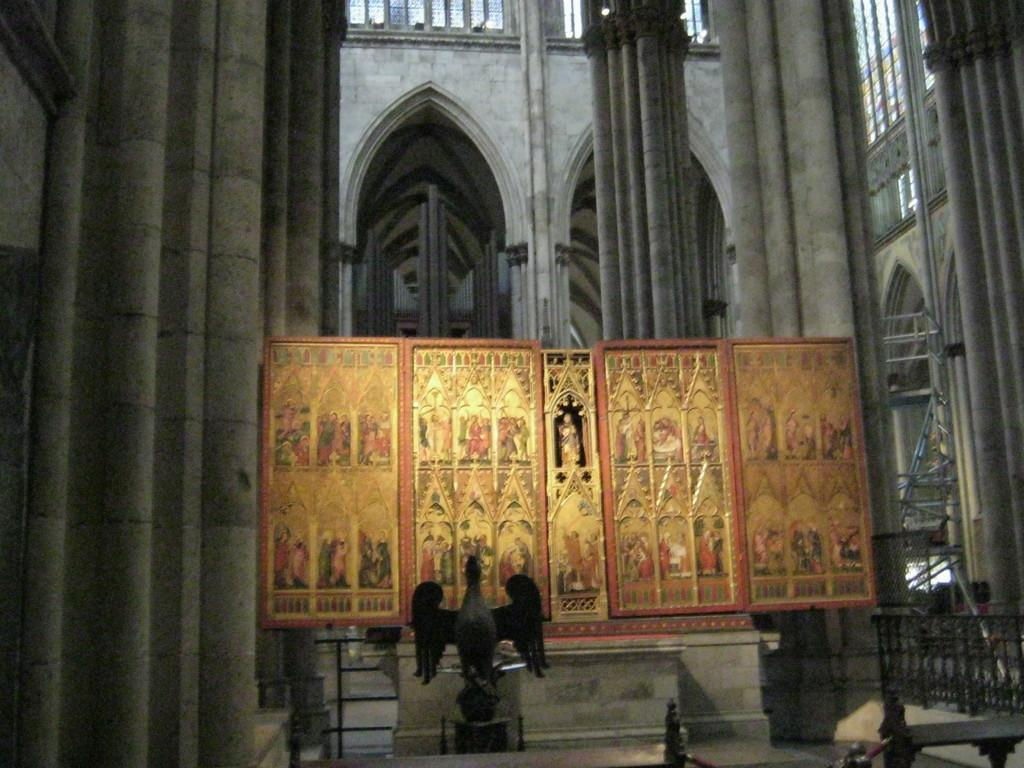What is the main subject in the image? There is a statue in the image. What else can be seen in the image besides the statue? There are boards with designs and railing in the image. Can you describe the interior of the building in the image? There are pillars inside the building in the image. What type of comb is being used by the statue in the image? There is no comb present in the image, as the statue is not using any object. 